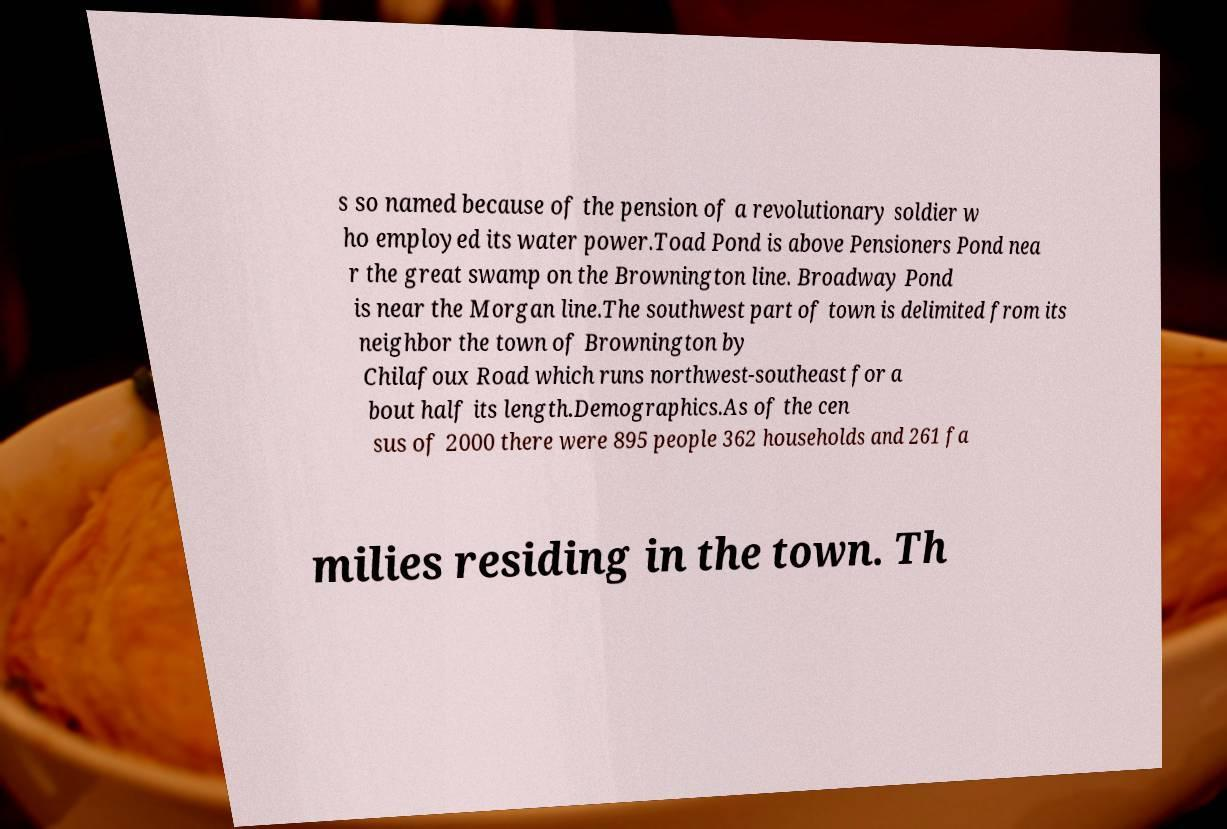What messages or text are displayed in this image? I need them in a readable, typed format. s so named because of the pension of a revolutionary soldier w ho employed its water power.Toad Pond is above Pensioners Pond nea r the great swamp on the Brownington line. Broadway Pond is near the Morgan line.The southwest part of town is delimited from its neighbor the town of Brownington by Chilafoux Road which runs northwest-southeast for a bout half its length.Demographics.As of the cen sus of 2000 there were 895 people 362 households and 261 fa milies residing in the town. Th 